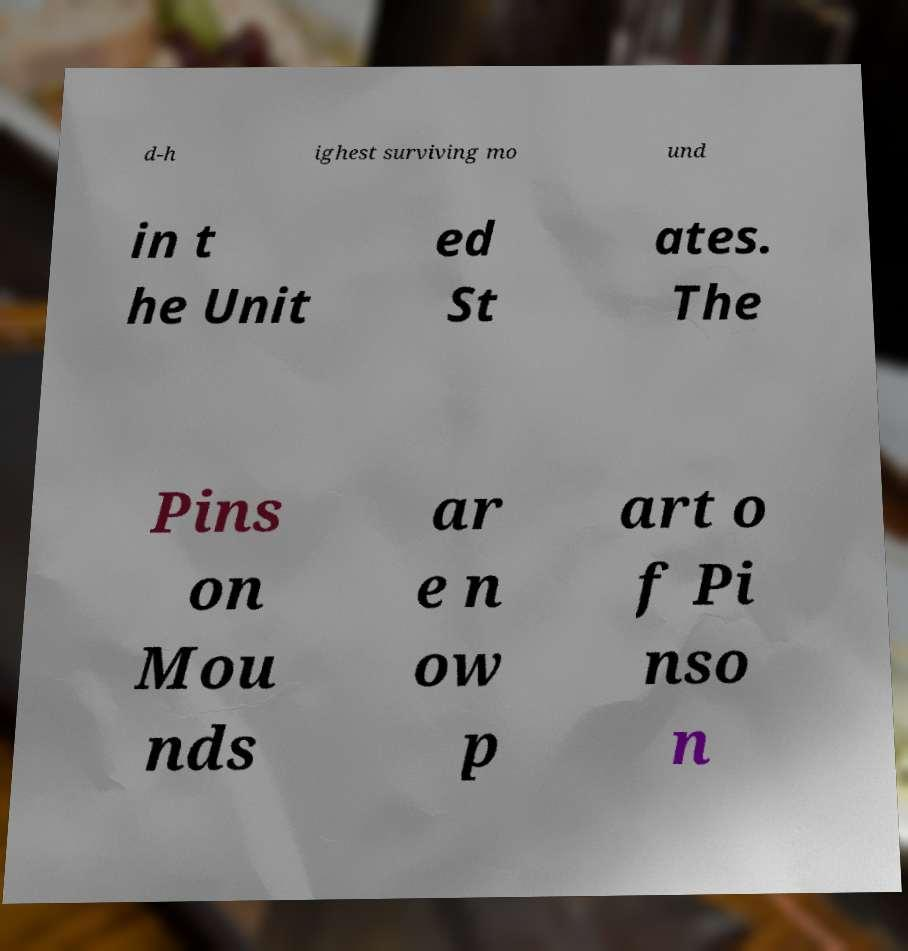Can you accurately transcribe the text from the provided image for me? d-h ighest surviving mo und in t he Unit ed St ates. The Pins on Mou nds ar e n ow p art o f Pi nso n 